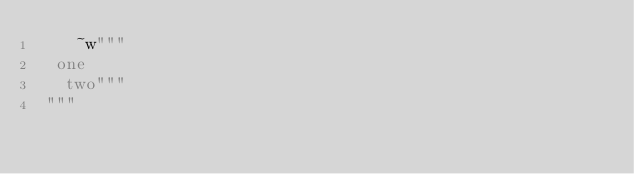<code> <loc_0><loc_0><loc_500><loc_500><_Elixir_>    ~w"""
  one
   two"""
 """</code> 